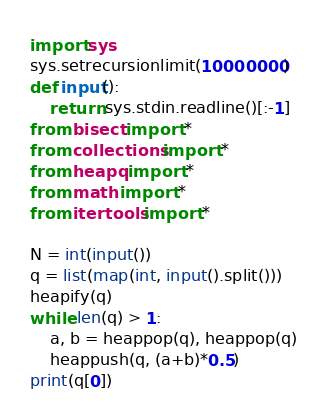<code> <loc_0><loc_0><loc_500><loc_500><_Python_>import sys
sys.setrecursionlimit(10000000)
def input():
    return sys.stdin.readline()[:-1]
from bisect import *
from collections import *
from heapq import *
from math import *
from itertools import *

N = int(input())
q = list(map(int, input().split()))
heapify(q)
while len(q) > 1:
    a, b = heappop(q), heappop(q)
    heappush(q, (a+b)*0.5)
print(q[0])
</code> 